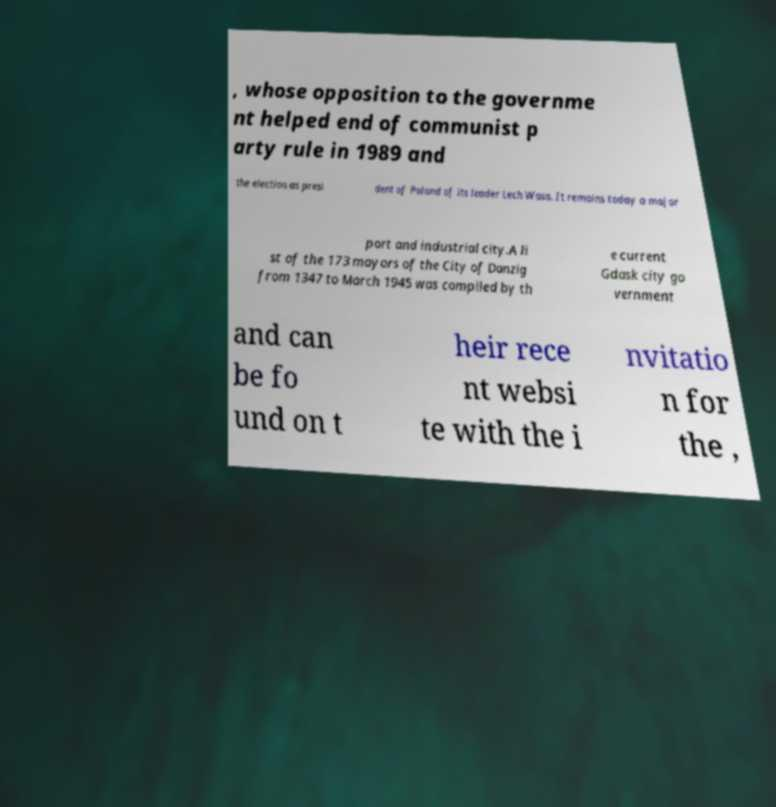Can you accurately transcribe the text from the provided image for me? , whose opposition to the governme nt helped end of communist p arty rule in 1989 and the election as presi dent of Poland of its leader Lech Wasa. It remains today a major port and industrial city.A li st of the 173 mayors of the City of Danzig from 1347 to March 1945 was compiled by th e current Gdask city go vernment and can be fo und on t heir rece nt websi te with the i nvitatio n for the , 